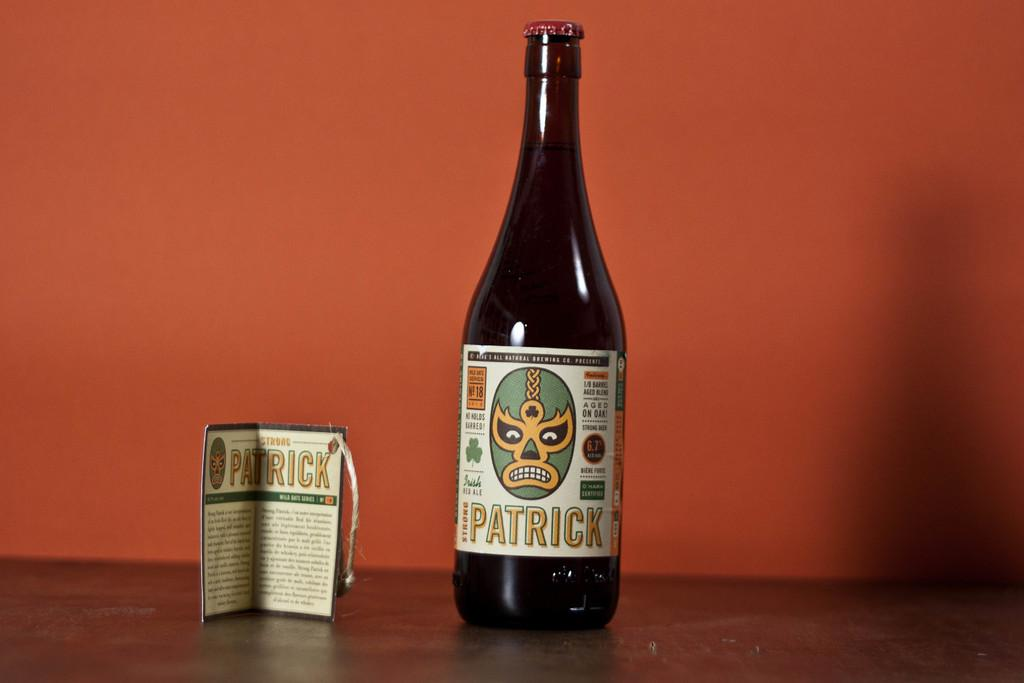What object can be seen in the image that is typically used for holding liquids? There is a bottle in the image that is typically used for holding liquids. What other object can be seen in the image? There is a card in the image. Where are the bottle and the card located in the image? Both the bottle and the card are on a surface in the image. What can be seen in the background of the image? There is a wall visible in the image. What type of grain is being used to create the pattern on the bottle in the image? There is no grain visible on the bottle in the image, and therefore no such pattern can be observed. 